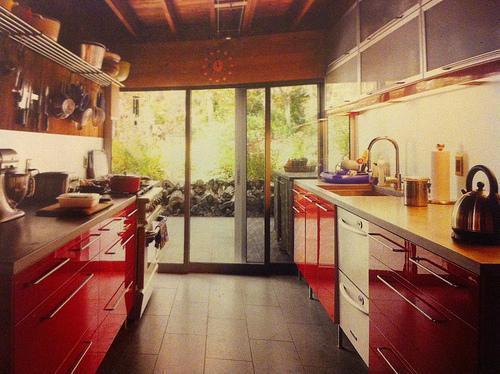How many doors?
Give a very brief answer. 2. 